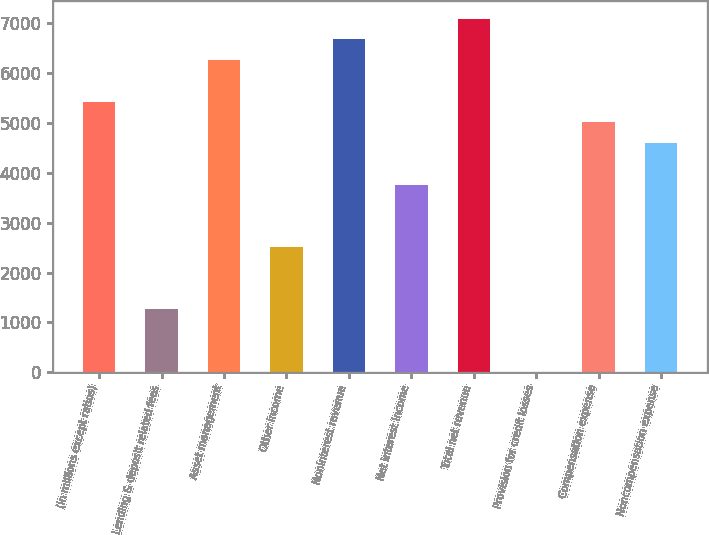Convert chart to OTSL. <chart><loc_0><loc_0><loc_500><loc_500><bar_chart><fcel>(in millions except ratios)<fcel>Lending & deposit related fees<fcel>Asset management<fcel>Other income<fcel>Noninterest revenue<fcel>Net interest income<fcel>Total net revenue<fcel>Provision for credit losses<fcel>Compensation expense<fcel>Noncompensation expense<nl><fcel>5428.5<fcel>1263.5<fcel>6261.5<fcel>2513<fcel>6678<fcel>3762.5<fcel>7094.5<fcel>14<fcel>5012<fcel>4595.5<nl></chart> 